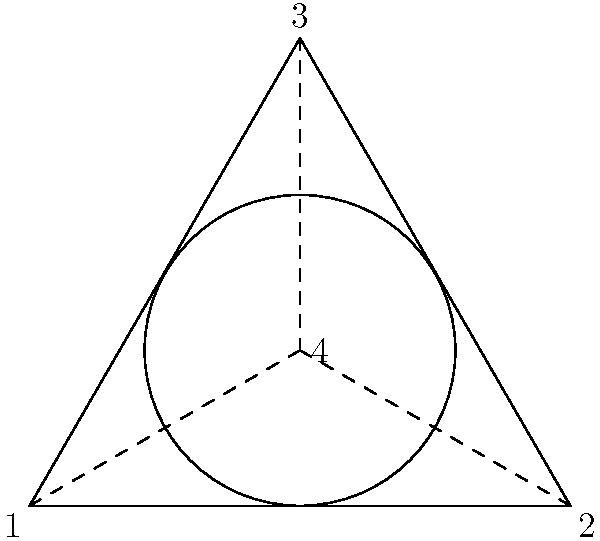Consider the simplified offshore oil rig design represented by the triangular base (points 1, 2, and 3) and the circular platform (centered at point 4). The symmetry group of this structure plays a crucial role in its structural integrity. If the symmetry group of this design has order 6, what is the maximum number of rotational symmetries possible for this structure? To solve this problem, we need to analyze the symmetry group of the given structure:

1. The structure has a triangular base and a circular platform.
2. The symmetry group has order 6, meaning there are 6 total symmetry operations.
3. For a 2D structure, symmetry operations can be rotations or reflections.

Let's consider the possible symmetries:

4. The triangular base has 3-fold rotational symmetry (120° rotations).
5. The circular platform has infinite rotational symmetry, but it's constrained by the triangular base.
6. The structure can have at most 3 lines of reflection symmetry (through each vertex and the midpoint of the opposite side).

Given that the total number of symmetry operations is 6:

7. If we have 3 reflection symmetries, we can have at most 3 rotational symmetries (including the identity rotation).
8. This is because the number of rotations and reflections must add up to the total order of the group (6).

Therefore, the maximum number of rotational symmetries possible for this structure is 3:
- 0° rotation (identity)
- 120° rotation
- 240° rotation
Answer: 3 